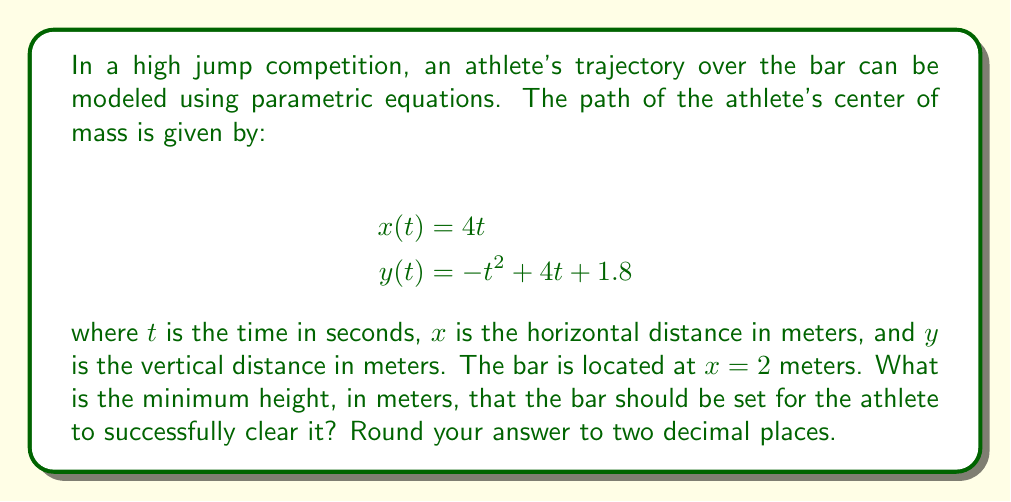Provide a solution to this math problem. To solve this problem, we'll follow these steps:

1) First, we need to find the $t$ value when the athlete is directly above the bar. This occurs when $x(t) = 2$:

   $4t = 2$
   $t = 0.5$ seconds

2) Now, we need to find the $y$ value at this time. We'll substitute $t = 0.5$ into the equation for $y(t)$:

   $y(0.5) = -(0.5)^2 + 4(0.5) + 1.8$
   $y(0.5) = -0.25 + 2 + 1.8$
   $y(0.5) = 3.55$ meters

3) However, this is not necessarily the minimum height needed. The athlete's path is parabolic, so the highest point might occur before or after the bar.

4) To find the maximum height of the jump, we need to find the vertex of the parabola described by $y(t)$. For a quadratic function $f(t) = at^2 + bt + c$, the t-coordinate of the vertex is given by $t = -b/(2a)$.

5) In our case, $a = -1$, $b = 4$, and $c = 1.8$. So:

   $t_{vertex} = -4 / (2(-1)) = 2$ seconds

6) The maximum height occurs at $t = 2$. Let's calculate $y(2)$:

   $y(2) = -(2)^2 + 4(2) + 1.8$
   $y(2) = -4 + 8 + 1.8$
   $y(2) = 5.8$ meters

7) This maximum height of 5.8 meters occurs after the athlete has passed the bar. The height at the bar (3.55 meters) is the minimum height needed to clear it.
Answer: The minimum height needed to clear the bar is 3.55 meters. 